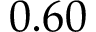Convert formula to latex. <formula><loc_0><loc_0><loc_500><loc_500>0 . 6 0</formula> 